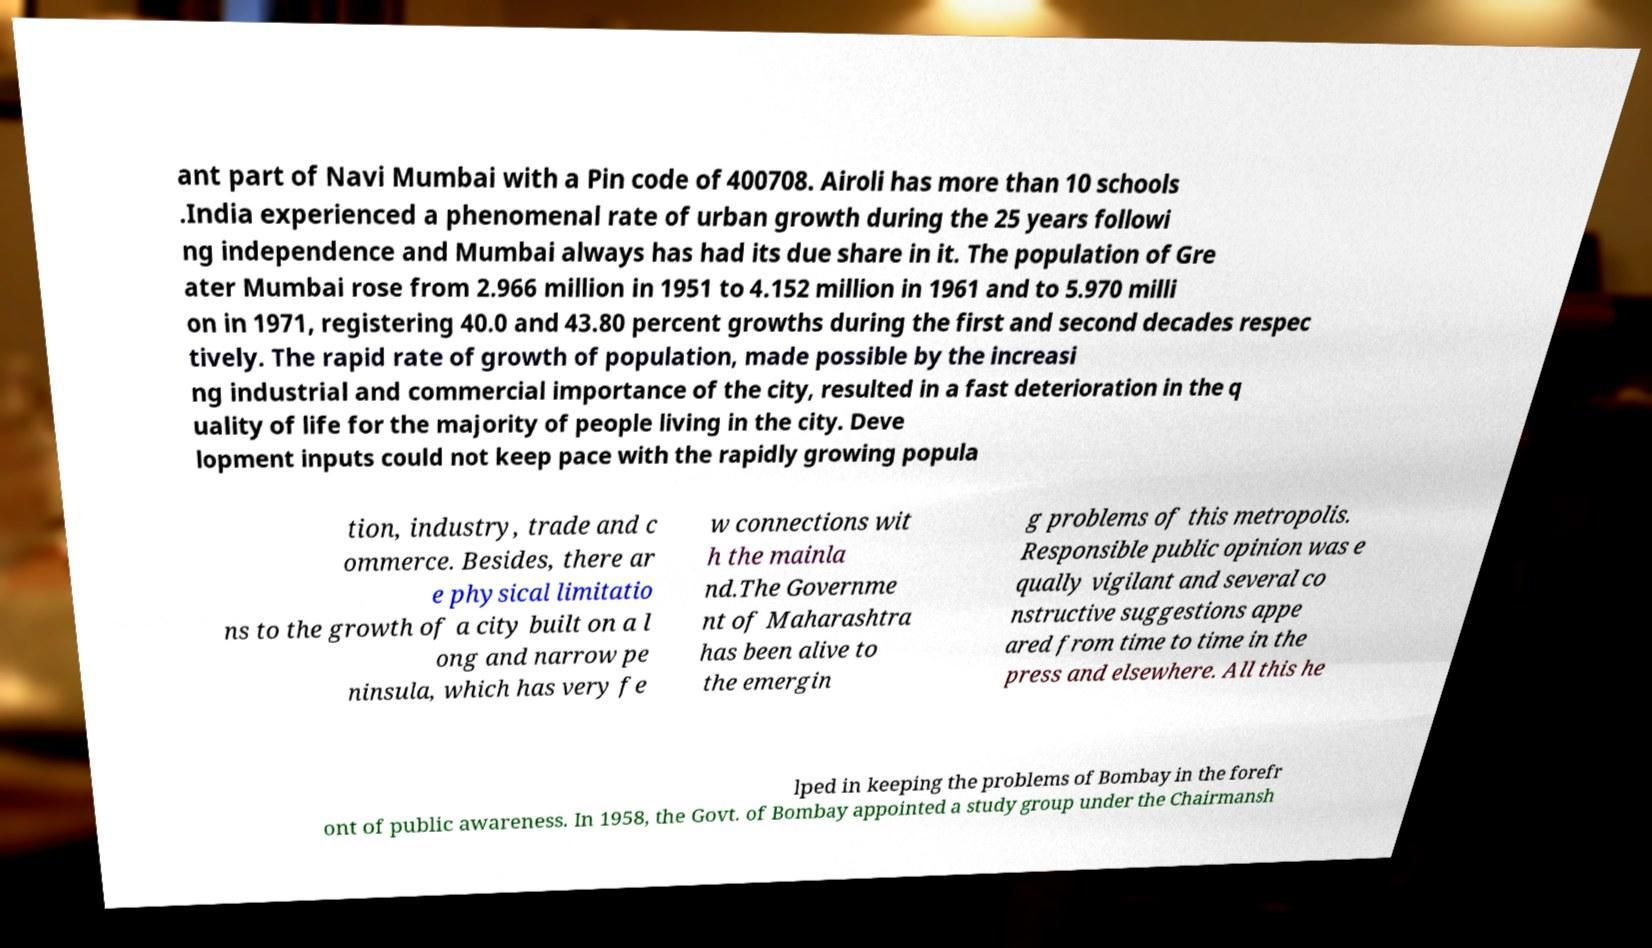Can you read and provide the text displayed in the image?This photo seems to have some interesting text. Can you extract and type it out for me? ant part of Navi Mumbai with a Pin code of 400708. Airoli has more than 10 schools .India experienced a phenomenal rate of urban growth during the 25 years followi ng independence and Mumbai always has had its due share in it. The population of Gre ater Mumbai rose from 2.966 million in 1951 to 4.152 million in 1961 and to 5.970 milli on in 1971, registering 40.0 and 43.80 percent growths during the first and second decades respec tively. The rapid rate of growth of population, made possible by the increasi ng industrial and commercial importance of the city, resulted in a fast deterioration in the q uality of life for the majority of people living in the city. Deve lopment inputs could not keep pace with the rapidly growing popula tion, industry, trade and c ommerce. Besides, there ar e physical limitatio ns to the growth of a city built on a l ong and narrow pe ninsula, which has very fe w connections wit h the mainla nd.The Governme nt of Maharashtra has been alive to the emergin g problems of this metropolis. Responsible public opinion was e qually vigilant and several co nstructive suggestions appe ared from time to time in the press and elsewhere. All this he lped in keeping the problems of Bombay in the forefr ont of public awareness. In 1958, the Govt. of Bombay appointed a study group under the Chairmansh 